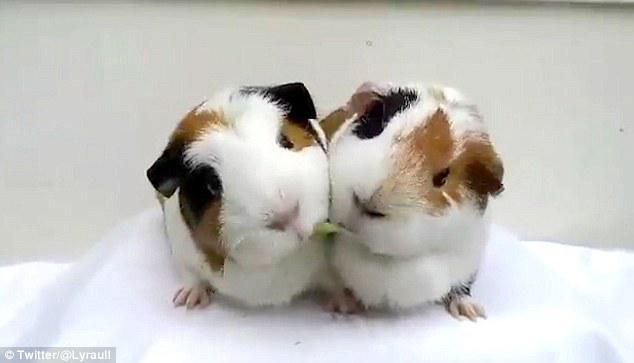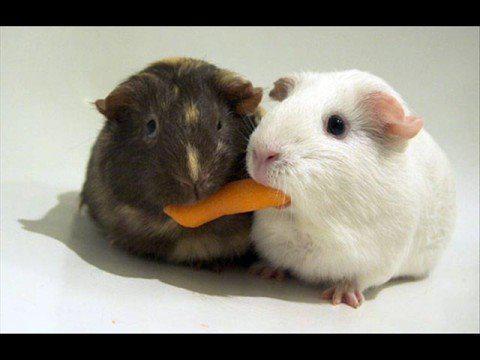The first image is the image on the left, the second image is the image on the right. Examine the images to the left and right. Is the description "The rodent in the image on the left sits on a surface to eat noodles." accurate? Answer yes or no. No. The first image is the image on the left, the second image is the image on the right. For the images displayed, is the sentence "A rodent is eating pasta in the left image." factually correct? Answer yes or no. No. 